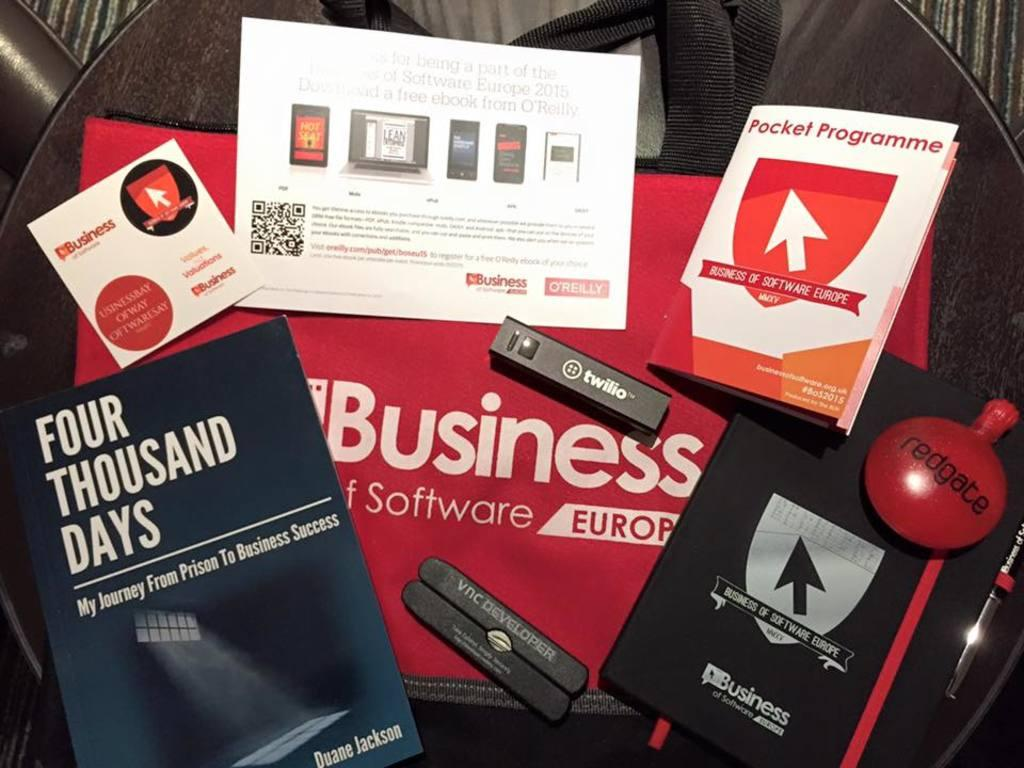Provide a one-sentence caption for the provided image. One of the many items is a book about becoming successful after prison. 